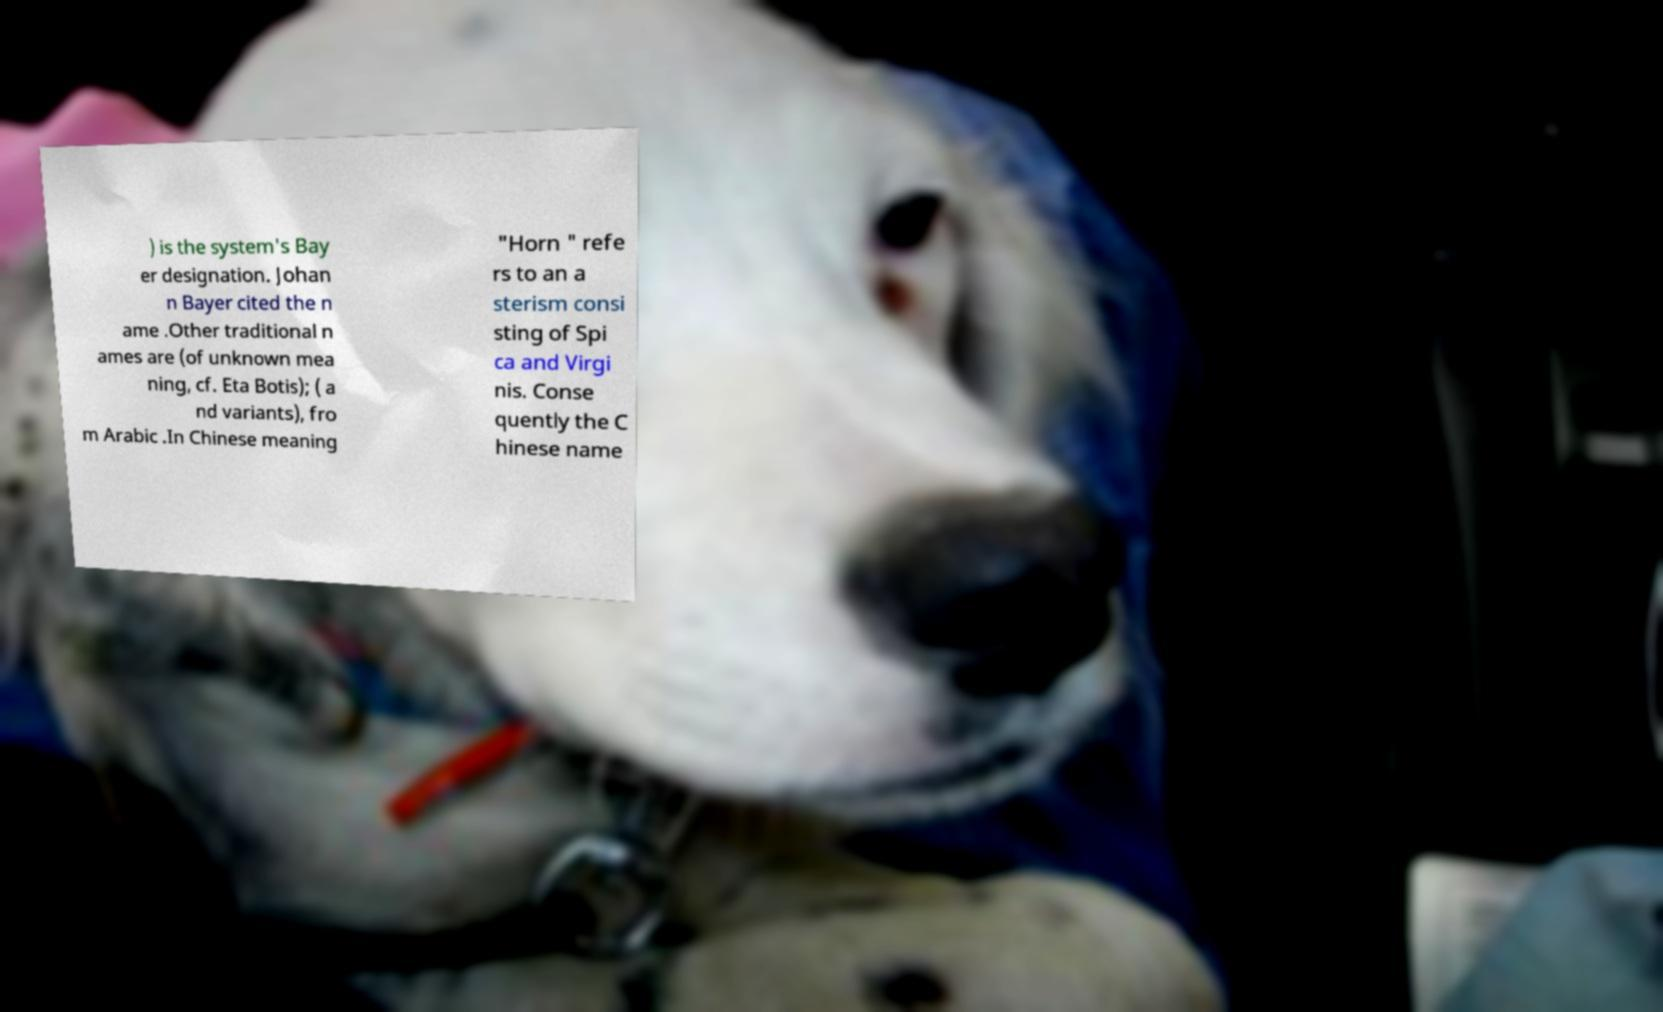Can you read and provide the text displayed in the image?This photo seems to have some interesting text. Can you extract and type it out for me? ) is the system's Bay er designation. Johan n Bayer cited the n ame .Other traditional n ames are (of unknown mea ning, cf. Eta Botis); ( a nd variants), fro m Arabic .In Chinese meaning "Horn " refe rs to an a sterism consi sting of Spi ca and Virgi nis. Conse quently the C hinese name 